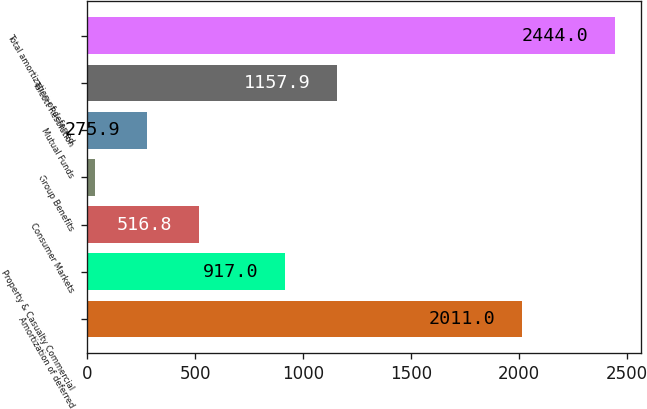Convert chart. <chart><loc_0><loc_0><loc_500><loc_500><bar_chart><fcel>Amortization of deferred<fcel>Property & Casualty Commercial<fcel>Consumer Markets<fcel>Group Benefits<fcel>Mutual Funds<fcel>Talcott Resolution<fcel>Total amortization of deferred<nl><fcel>2011<fcel>917<fcel>516.8<fcel>35<fcel>275.9<fcel>1157.9<fcel>2444<nl></chart> 